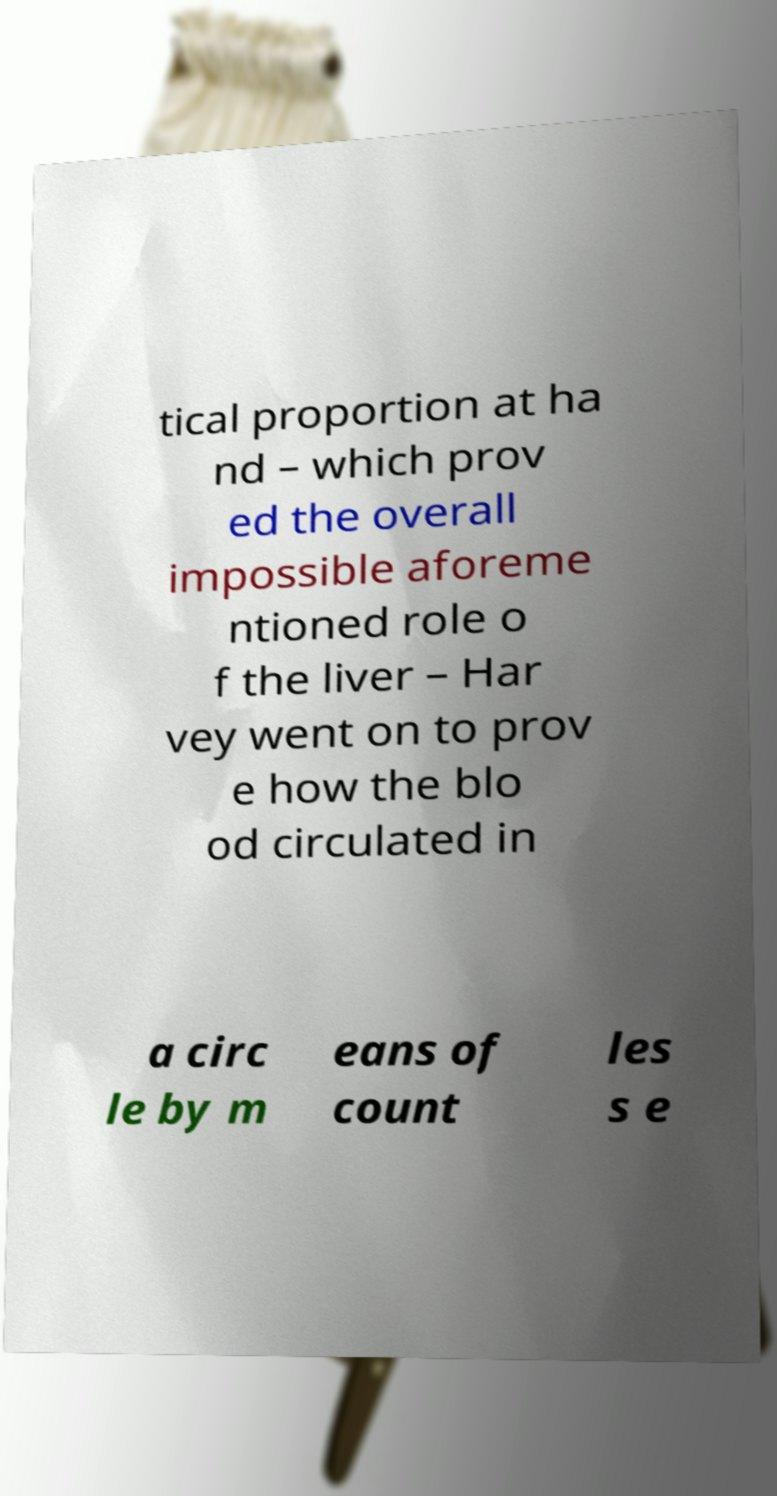Can you accurately transcribe the text from the provided image for me? tical proportion at ha nd – which prov ed the overall impossible aforeme ntioned role o f the liver – Har vey went on to prov e how the blo od circulated in a circ le by m eans of count les s e 